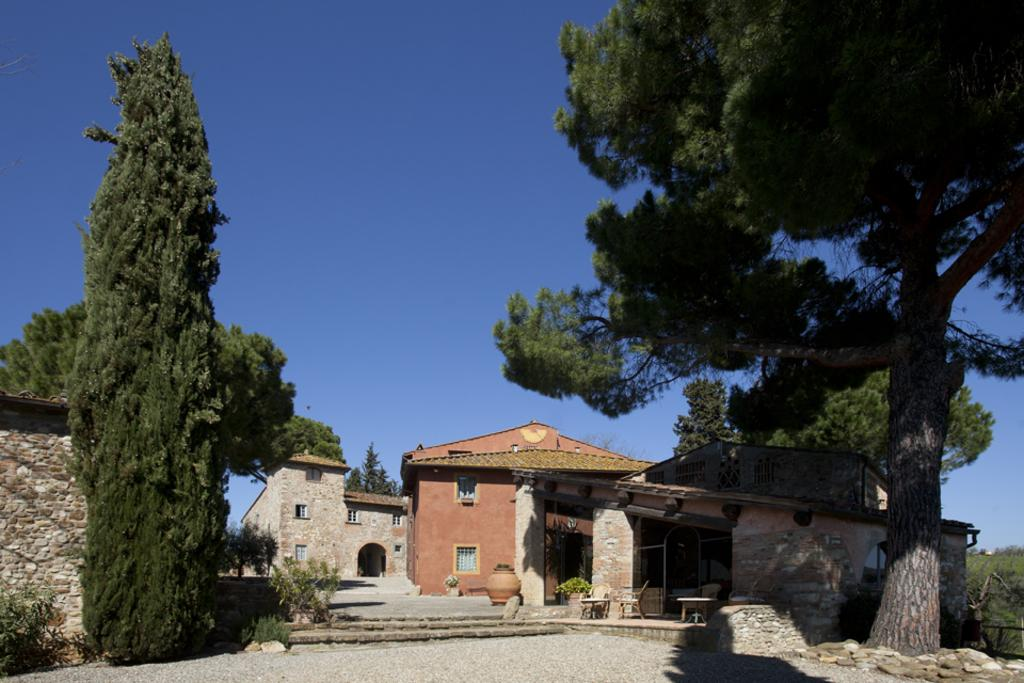What type of structures can be seen in the image? There are buildings in the image. What architectural features are present in the buildings? There are windows and stairs visible in the image. What type of furniture is present in the image? There are tables and chairs in the image. What type of vegetation can be seen in the image? There are trees in the image. What is the color of the sky in the image? The sky is blue in color. Where is the cactus located in the image? There is no cactus present in the image. What type of country is depicted in the image? The image does not depict a country; it shows buildings, windows, stairs, tables, chairs, trees, and a blue sky. 